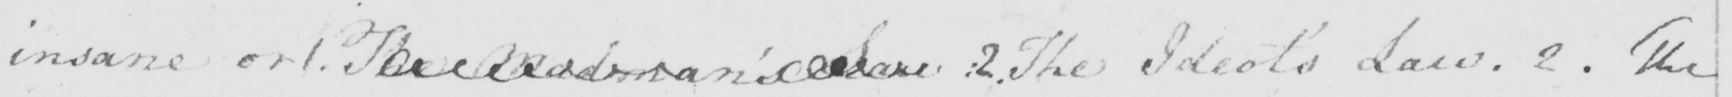What is written in this line of handwriting? insane or 1 . The Madman ' s Law :  2 . The Ideot ' s Law . 2 . The 